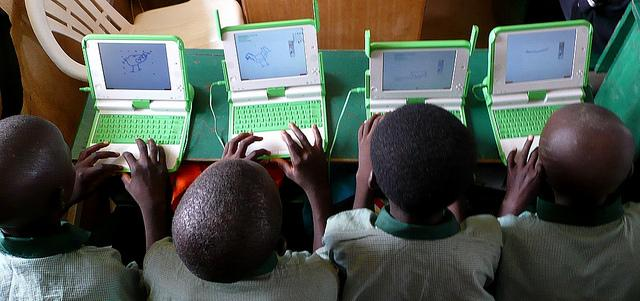Why are all the boys dressed alike? school uniforms 